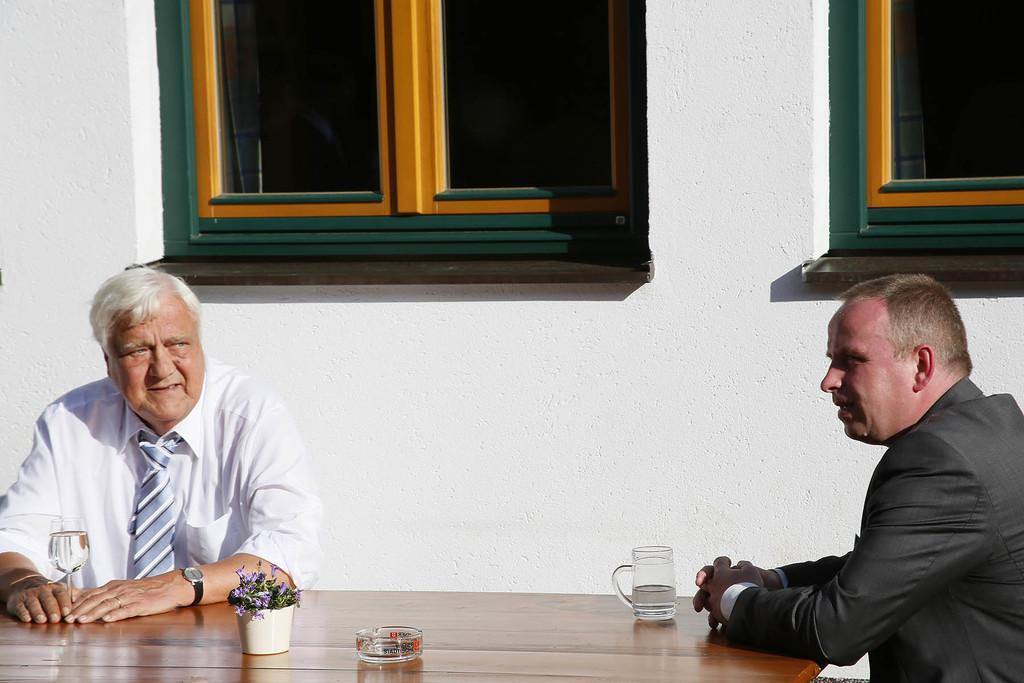Describe this image in one or two sentences. In the foreground of this image, there are two persons, one in white dress and another in black. They are sitting near a table on which glasses, a small plant and a small bowl placed on it. In the background, there is a wall and two windows. 